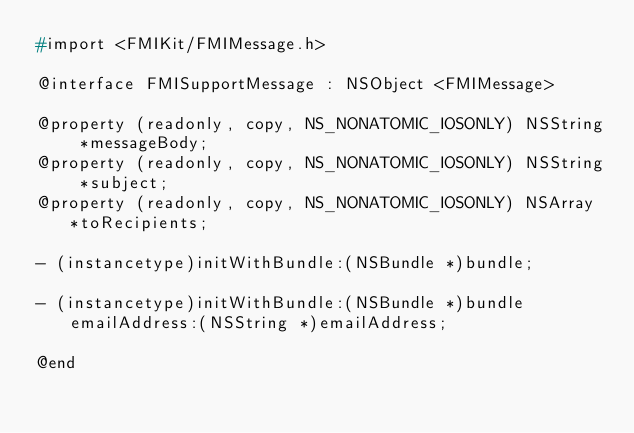<code> <loc_0><loc_0><loc_500><loc_500><_C_>#import <FMIKit/FMIMessage.h>

@interface FMISupportMessage : NSObject <FMIMessage>

@property (readonly, copy, NS_NONATOMIC_IOSONLY) NSString *messageBody;
@property (readonly, copy, NS_NONATOMIC_IOSONLY) NSString *subject;
@property (readonly, copy, NS_NONATOMIC_IOSONLY) NSArray *toRecipients;

- (instancetype)initWithBundle:(NSBundle *)bundle;

- (instancetype)initWithBundle:(NSBundle *)bundle emailAddress:(NSString *)emailAddress;

@end
</code> 